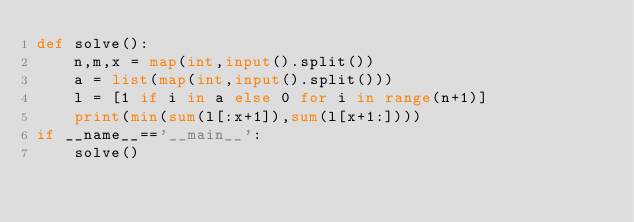Convert code to text. <code><loc_0><loc_0><loc_500><loc_500><_Python_>def solve():
    n,m,x = map(int,input().split())
    a = list(map(int,input().split()))
    l = [1 if i in a else 0 for i in range(n+1)]
    print(min(sum(l[:x+1]),sum(l[x+1:])))
if __name__=='__main__':
    solve()</code> 